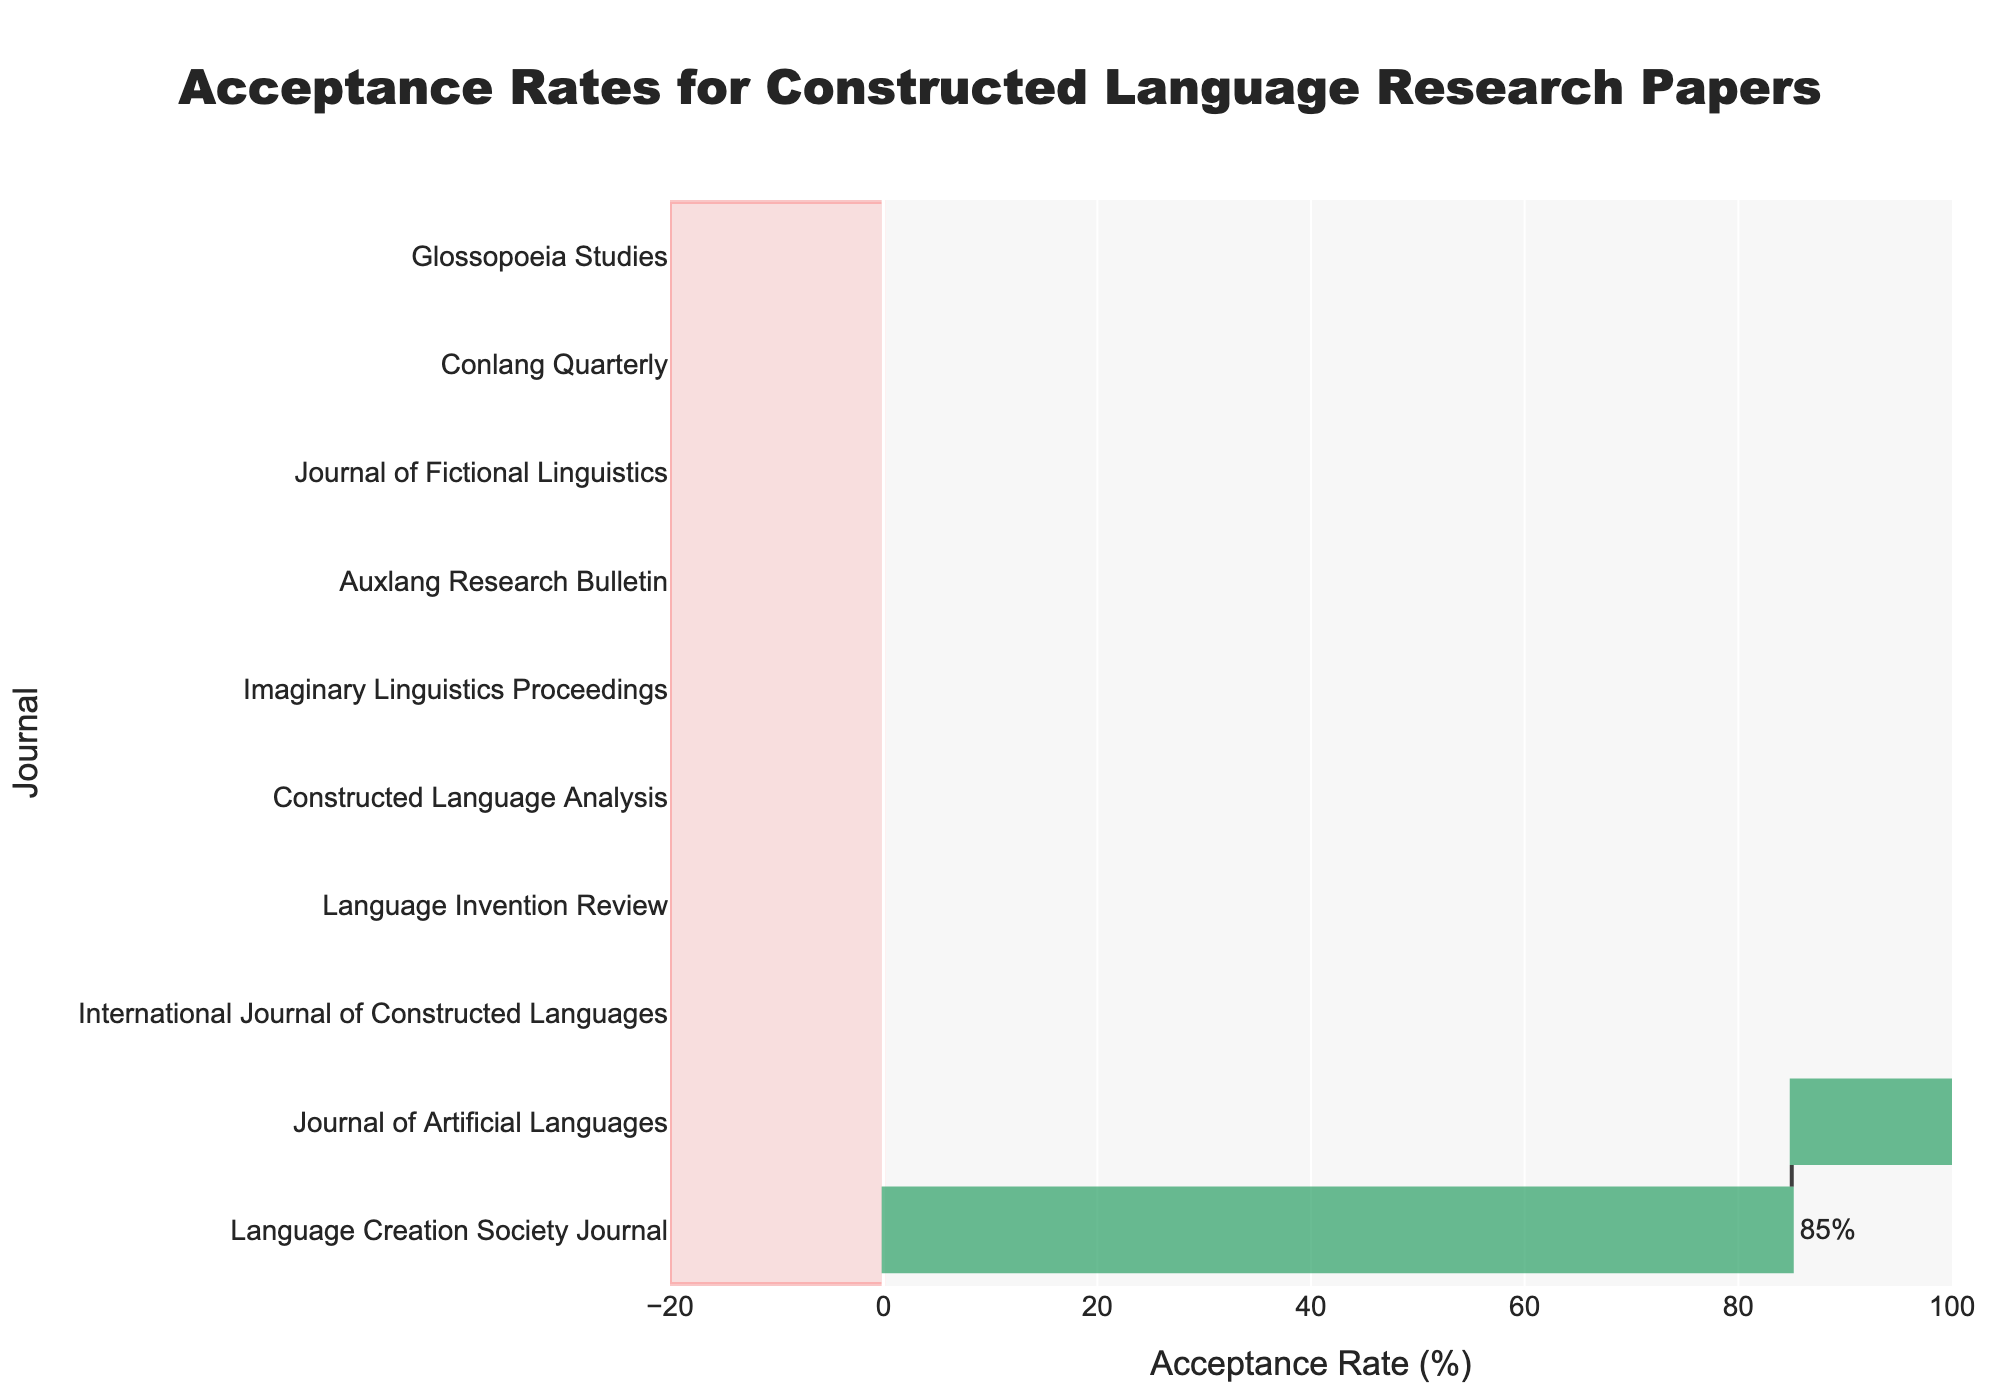What is the title of the chart? The title of the chart is located at the top and reads "Acceptance Rates for Constructed Language Research Papers".
Answer: Acceptance Rates for Constructed Language Research Papers How many journals are represented in the chart? By counting the entries along the y-axis, which lists all the journals, we can see that there are 10 journals represented.
Answer: 10 Which journal has the highest acceptance rate? By looking at the bar that extends the furthest to the right, we see that the "Language Creation Society Journal" has the highest acceptance rate.
Answer: Language Creation Society Journal What is the acceptance rate for the Journal of Artificial Languages? Find the bar corresponding to the "Journal of Artificial Languages" and read the label at the end of the bar. It indicates an acceptance rate of 72%.
Answer: 72% Which journals have negative acceptance rates? By looking at the bars that extend to the left into the shaded red rectangle, we see that "Conlang Quarterly", "Glossopoeia Studies", "Journal of Fictional Linguistics", and "Auxlang Research Bulletin" have negative acceptance rates.
Answer: Conlang Quarterly, Glossopoeia Studies, Journal of Fictional Linguistics, Auxlang Research Bulletin What is the range of acceptance rates shown in the chart? The highest acceptance rate is 85% for the "Language Creation Society Journal" and the lowest is -12% for "Glossopoeia Studies", so the range is calculated by subtracting -12 from 85, which gives us 97%.
Answer: 97% Which journal has an acceptance rate just below 60%? By examining the entries close to 60%, we see that the "Language Invention Review" journal has an acceptance rate of 58%, which is just below 60%.
Answer: Language Invention Review What is the average acceptance rate among all journals? Sum the acceptance rates (85 + 72 + (-8) + 63 + (-12) + 58 + (-7) + 52 + (-5) + 47) which equals 345. Then divide by the number of journals, 10: 345 / 10 = 34.5%.
Answer: 34.5% How many journals have acceptance rates below 50%? Count the number of journals with bars that fall below the 50% mark. They are "Journal of Fictional Linguistics", "Conlang Quarterly", "Auxlang Research Bulletin", and "Glossopoeia Studies". This totals to 4 journals.
Answer: 4 Which journal has an acceptance rate closest to the average rate? The average acceptance rate is 34.5%. The closest journal to this average is the "Constructed Language Analysis" with an acceptance rate of 52%.
Answer: Constructed Language Analysis 